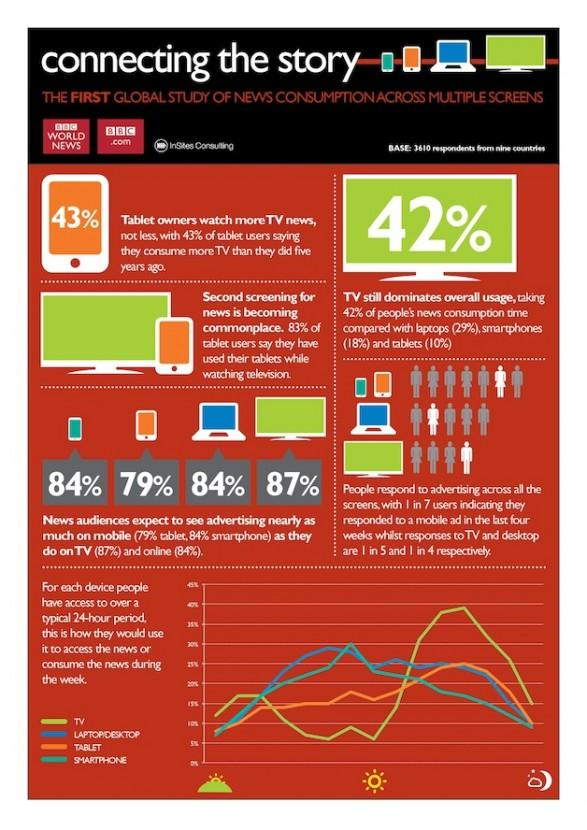Mention a couple of crucial points in this snapshot. According to a survey, a substantial portion of news audiences, or 163%, expect to see advertising on mobile and tablet devices. A recent study found that an overwhelming 84% of news audiences expect to see advertising on mobile devices. 